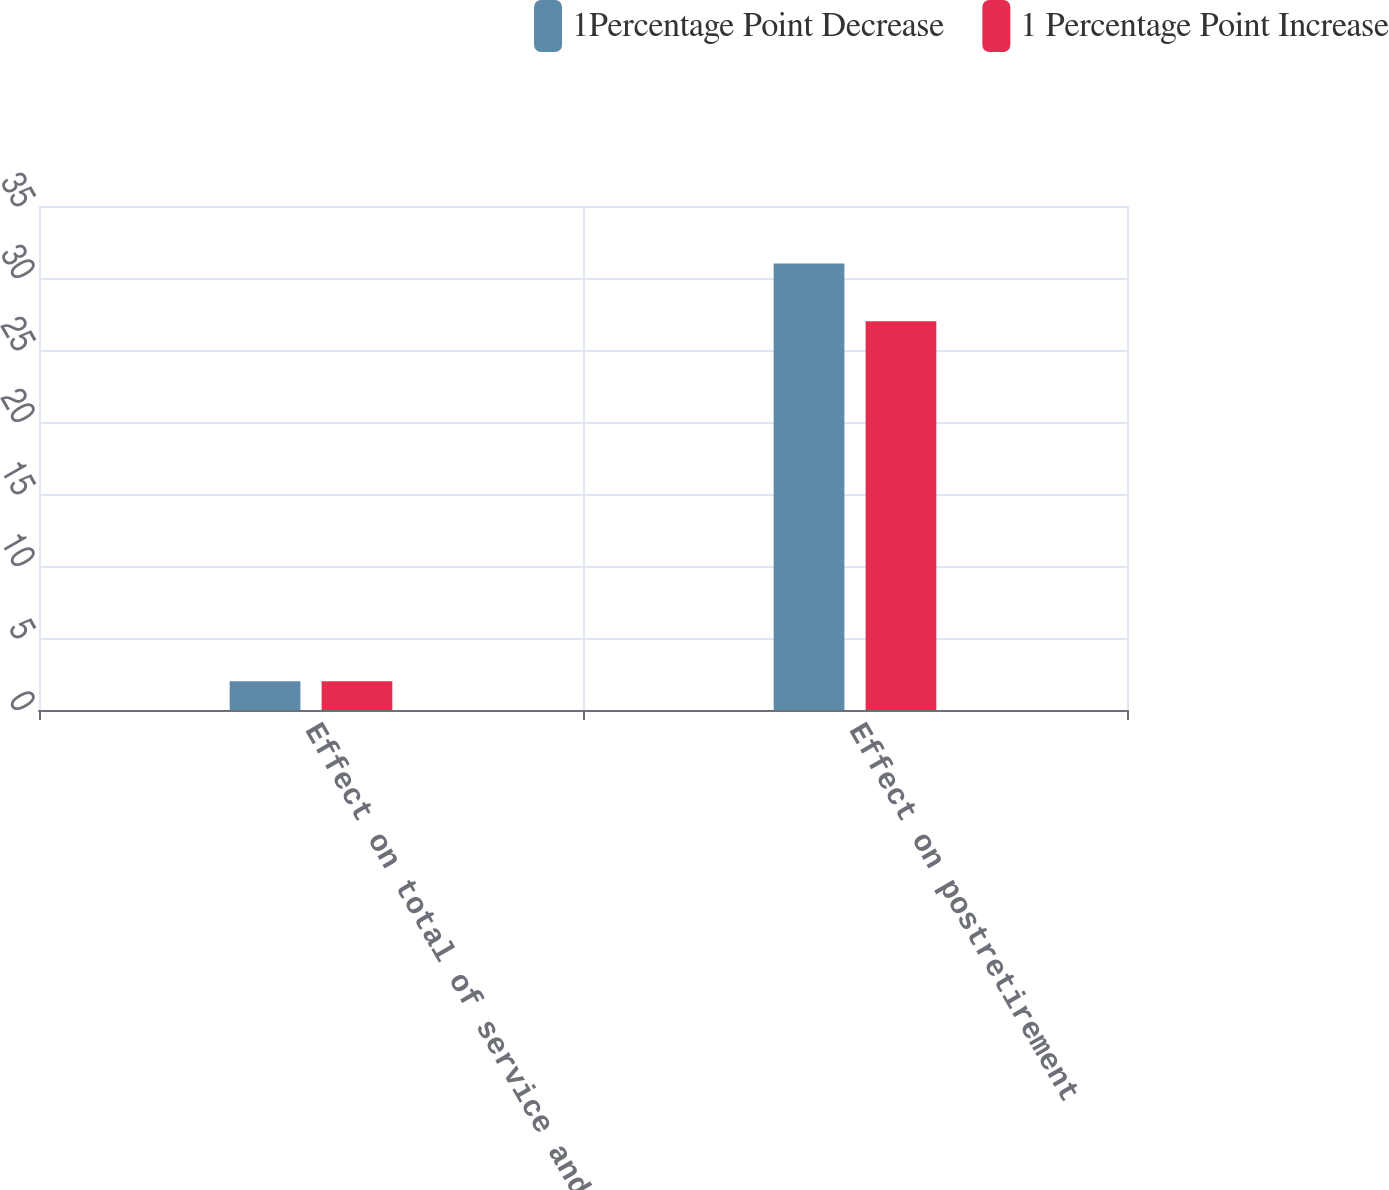Convert chart to OTSL. <chart><loc_0><loc_0><loc_500><loc_500><stacked_bar_chart><ecel><fcel>Effect on total of service and<fcel>Effect on postretirement<nl><fcel>1Percentage Point Decrease<fcel>2<fcel>31<nl><fcel>1 Percentage Point Increase<fcel>2<fcel>27<nl></chart> 